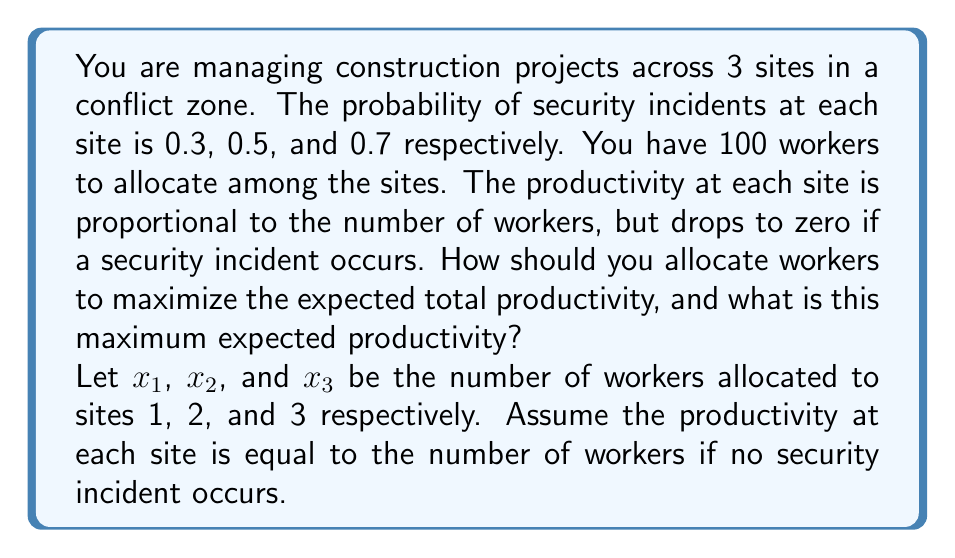Teach me how to tackle this problem. To solve this problem, we'll use Bayesian decision theory and expected value calculations.

1) First, let's define our objective function. The expected productivity for each site is:

   Site 1: $E_1 = x_1 \cdot (1-0.3) = 0.7x_1$
   Site 2: $E_2 = x_2 \cdot (1-0.5) = 0.5x_2$
   Site 3: $E_3 = x_3 \cdot (1-0.7) = 0.3x_3$

2) The total expected productivity is the sum of these:

   $E_{total} = 0.7x_1 + 0.5x_2 + 0.3x_3$

3) We want to maximize $E_{total}$ subject to the constraint:

   $x_1 + x_2 + x_3 = 100$

4) This is a linear programming problem. The optimal solution will allocate all workers to the site with the highest expected productivity per worker, which is Site 1.

5) Therefore, the optimal allocation is:

   $x_1 = 100$, $x_2 = 0$, $x_3 = 0$

6) The maximum expected productivity is:

   $E_{max} = 0.7 \cdot 100 + 0.5 \cdot 0 + 0.3 \cdot 0 = 70$
Answer: Optimal allocation: 100 workers to Site 1, 0 to Site 2, 0 to Site 3.
Maximum expected productivity: 70 